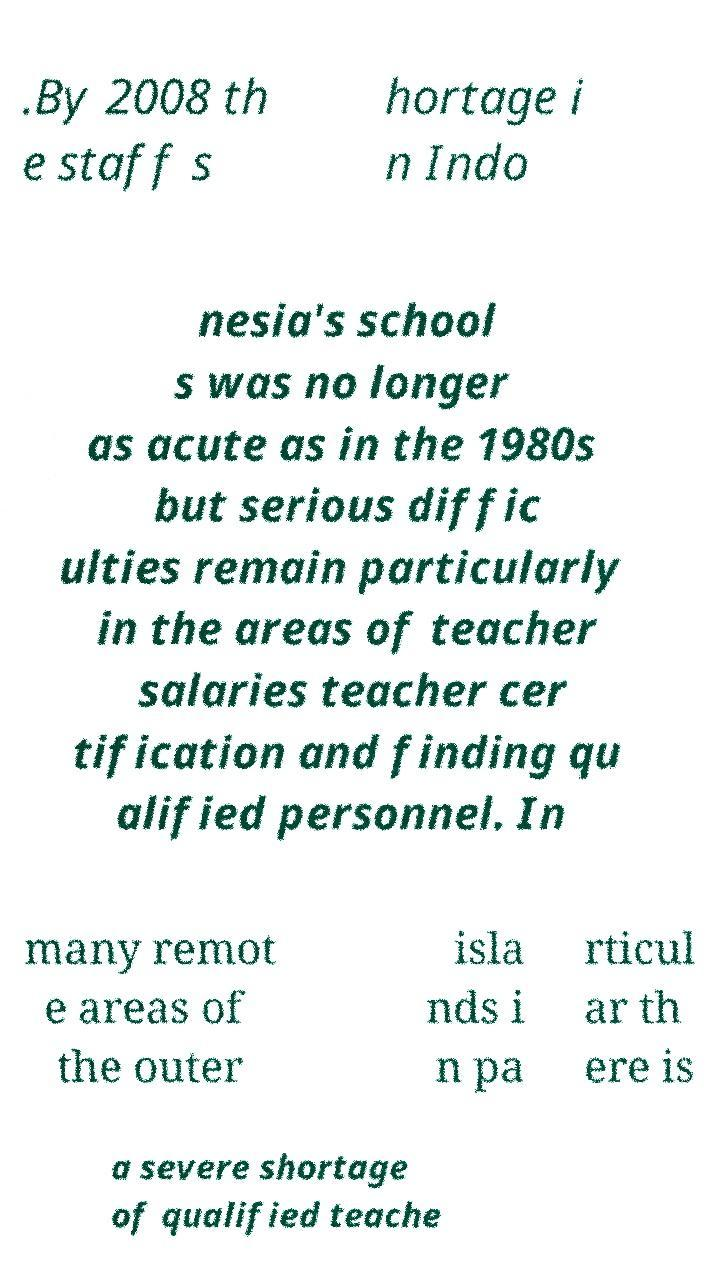Could you extract and type out the text from this image? .By 2008 th e staff s hortage i n Indo nesia's school s was no longer as acute as in the 1980s but serious diffic ulties remain particularly in the areas of teacher salaries teacher cer tification and finding qu alified personnel. In many remot e areas of the outer isla nds i n pa rticul ar th ere is a severe shortage of qualified teache 